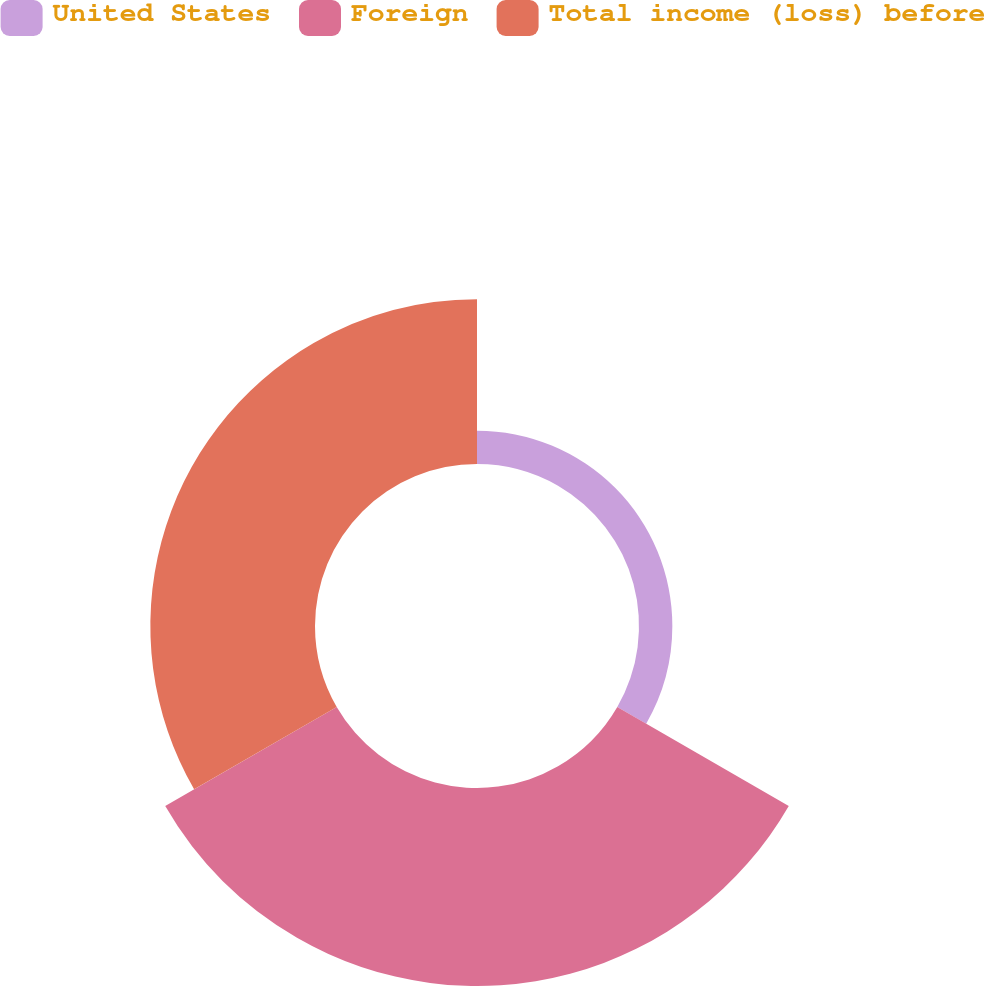Convert chart to OTSL. <chart><loc_0><loc_0><loc_500><loc_500><pie_chart><fcel>United States<fcel>Foreign<fcel>Total income (loss) before<nl><fcel>8.42%<fcel>50.0%<fcel>41.58%<nl></chart> 